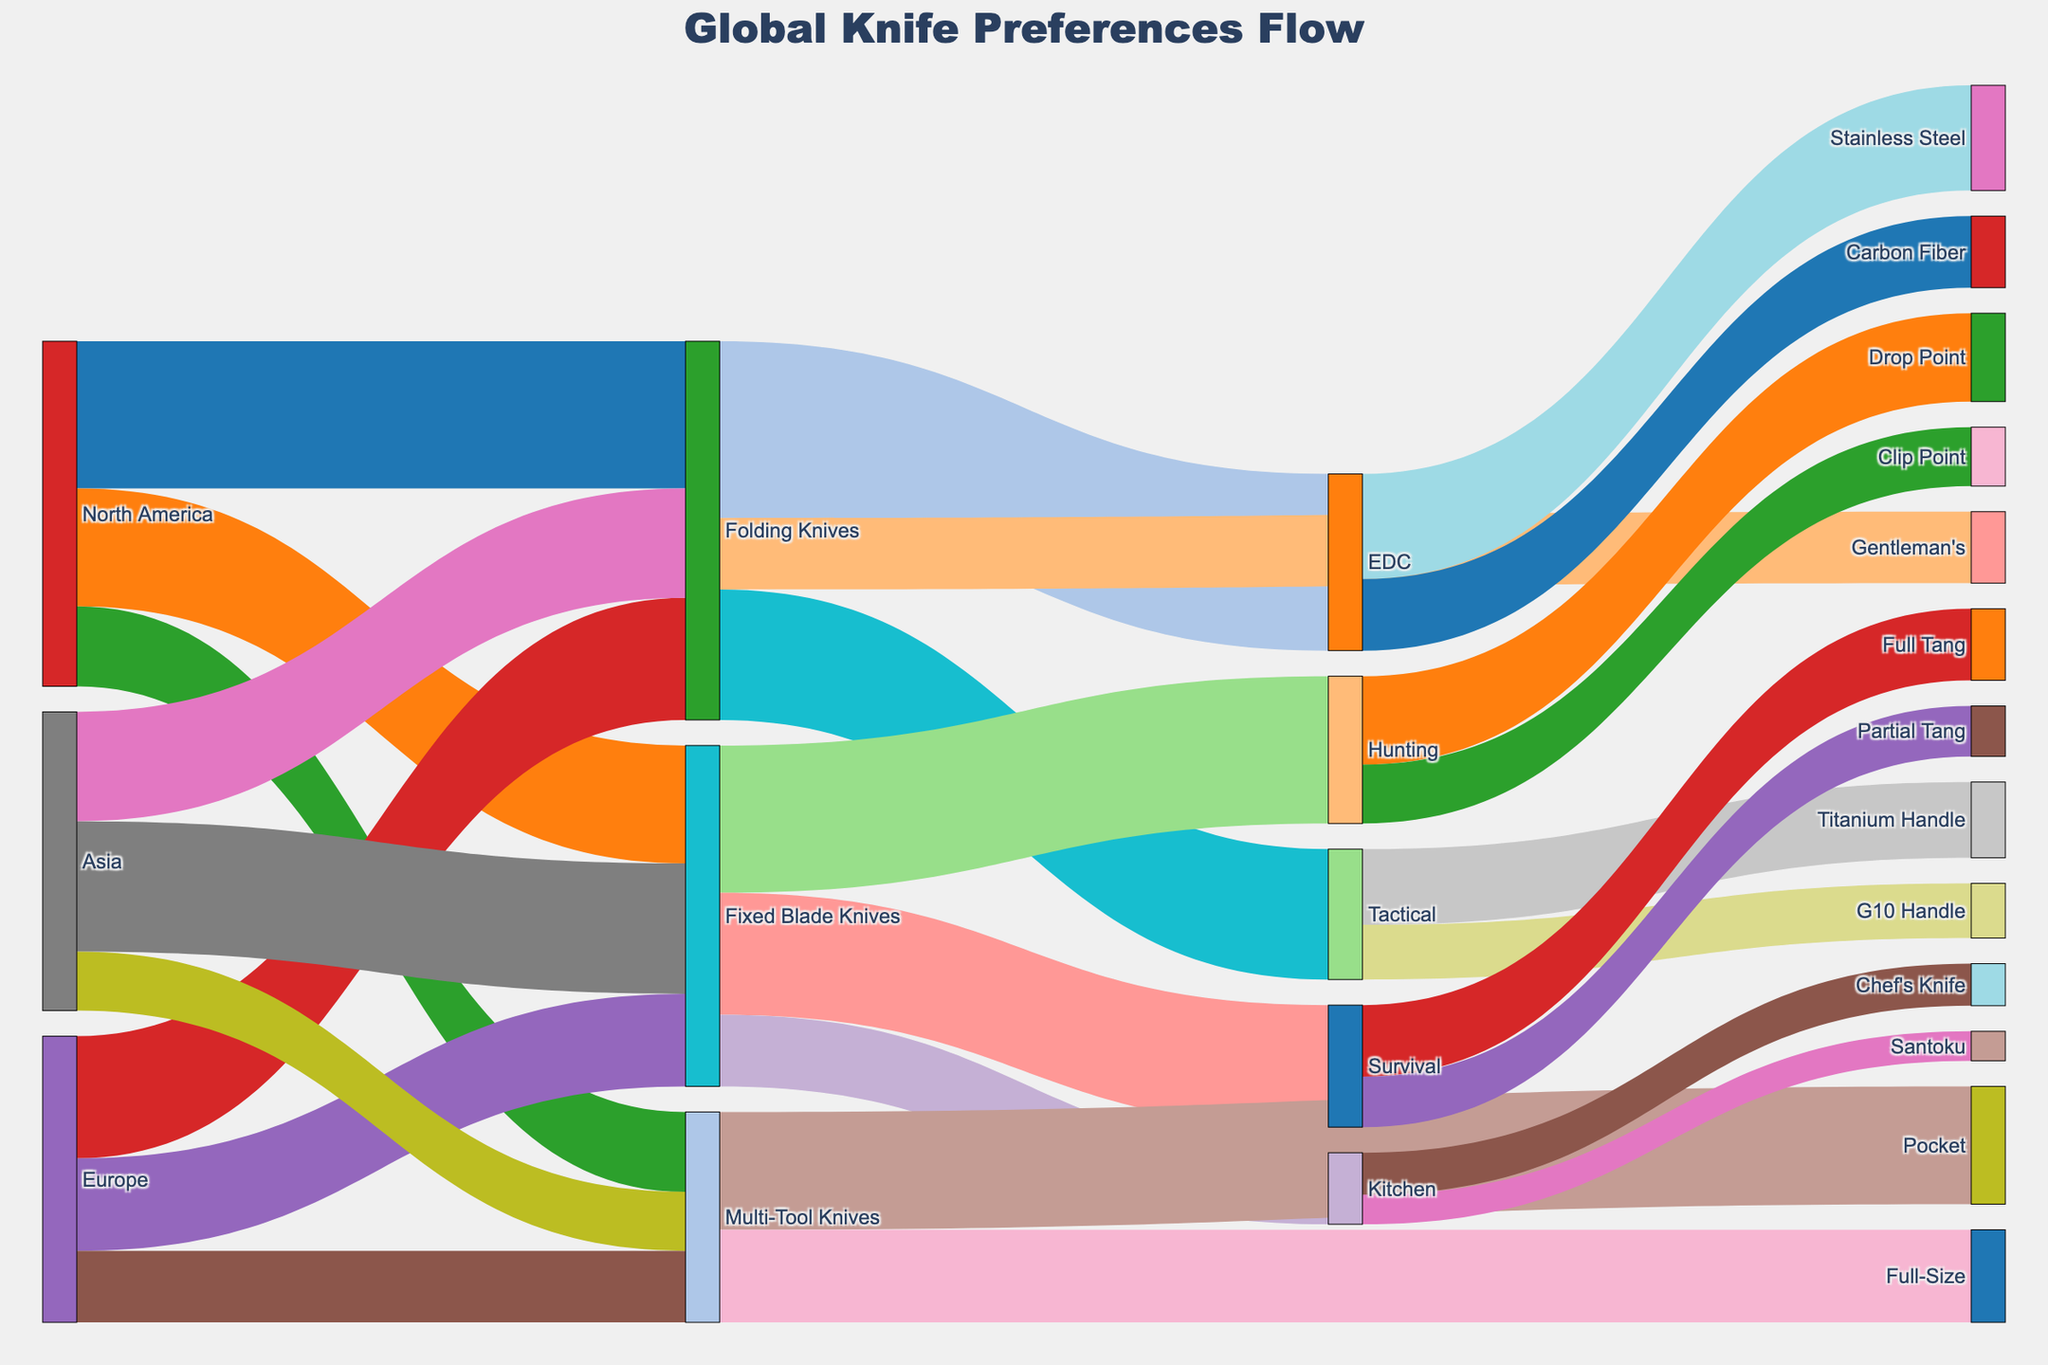What is the title of the Sankey Diagram? The title is located at the top of the diagram, intended to provide a concise description of the visualized data.
Answer: Global Knife Preferences Flow Which knife style is most preferred in North America? By following the flow lines from "North America" to different knife styles, it is evident that the line representing "Folding Knives" has the highest value.
Answer: Folding Knives How many knife preferences flow from Europe? By adding the values flowing out of "Europe" node: 2900 (Folding Knives) + 2200 (Fixed Blade Knives) + 1700 (Multi-Tool Knives) = 6800.
Answer: 6800 Which market has the highest preference for Fixed Blade Knives? Compare the flow values from "Fixed Blade Knives" for North America (2800), Europe (2200), and Asia (3100). Asia has the highest value.
Answer: Asia How many preferences are there for Full Tang knives? Trace all flows to "Full Tang" and sum the values: 1700.
Answer: 1700 What is the most preferred variation of Folding Knives? By following the flows from "Folding Knives" and comparing values (3100 for Tactical, 4200 for EDC, 1700 for Gentleman's), "EDC" is most preferred.
Answer: EDC Which knife handle material is least preferred for Tactical knives? Compare the flow values for "Tactical" knives: 1800 for Titanium Handle, 1300 for G10 Handle. G10 Handle is least preferred.
Answer: G10 Handle How many knife preferences flow into the EDC category? By summing the values from "EDC" flows: 2500 (Stainless Steel) + 1700 (Carbon Fiber) = 4200.
Answer: 4200 Which knife category is least preferred in Asia? Compare the outflows from "Asia" node: 2600 (Folding Knives), 3100 (Fixed Blade Knives), 1400 (Multi-Tool Knives). The least preferred is Multi-Tool Knives.
Answer: Multi-Tool Knives 